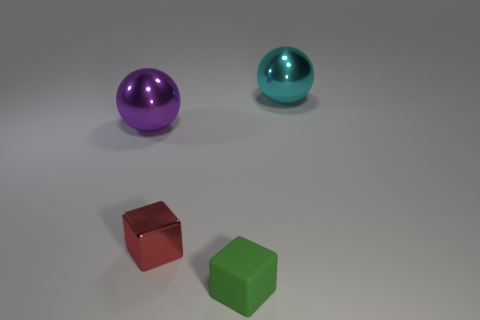Is the number of green blocks greater than the number of tiny gray shiny spheres?
Offer a terse response. Yes. There is a big metal thing on the right side of the metallic block; is its shape the same as the large purple metal object?
Your response must be concise. Yes. Is the number of large gray things less than the number of blocks?
Make the answer very short. Yes. What material is the other object that is the same size as the matte object?
Keep it short and to the point. Metal. Is the color of the matte object the same as the sphere on the left side of the tiny metal block?
Make the answer very short. No. Are there fewer tiny green matte cubes behind the big cyan thing than large cylinders?
Offer a terse response. No. What number of large purple rubber cylinders are there?
Give a very brief answer. 0. What shape is the large shiny object that is left of the big thing on the right side of the green block?
Ensure brevity in your answer.  Sphere. There is a matte block; what number of matte things are in front of it?
Make the answer very short. 0. Are the tiny green cube and the big ball in front of the large cyan metallic object made of the same material?
Your response must be concise. No. 